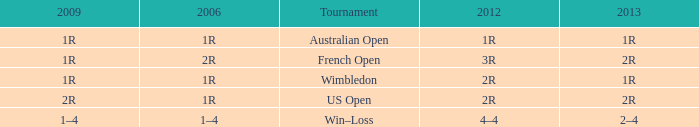What is the 2006 when the 2013 is 1r, and the 2012 is 1r? 1R. 